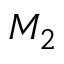Convert formula to latex. <formula><loc_0><loc_0><loc_500><loc_500>M _ { 2 }</formula> 